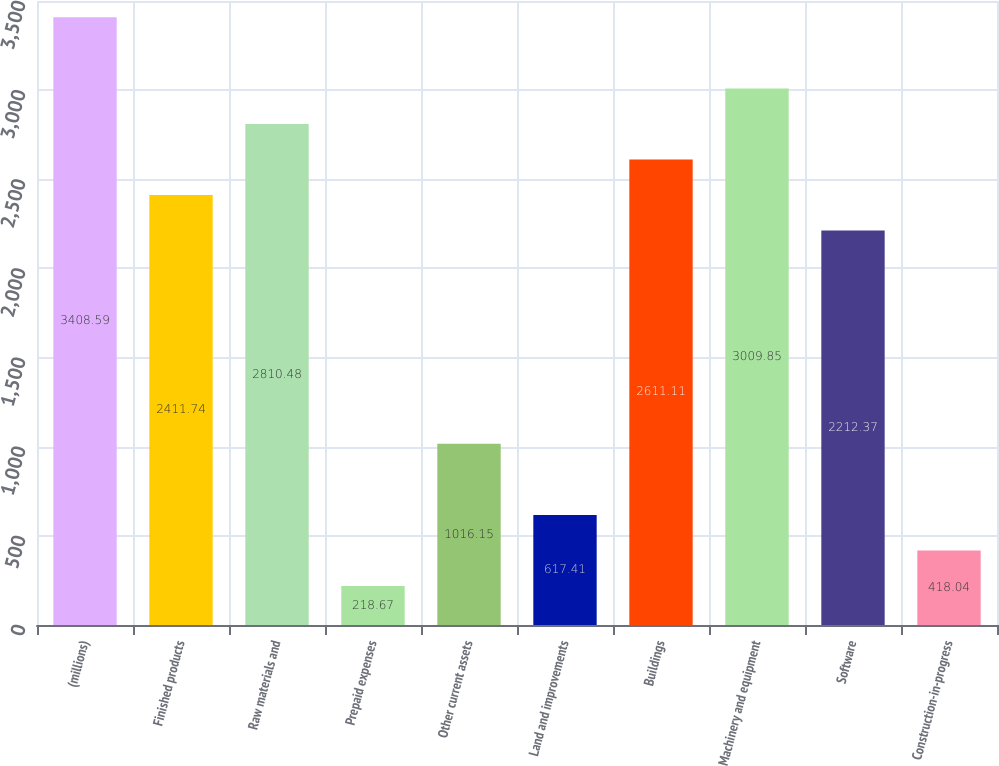Convert chart to OTSL. <chart><loc_0><loc_0><loc_500><loc_500><bar_chart><fcel>(millions)<fcel>Finished products<fcel>Raw materials and<fcel>Prepaid expenses<fcel>Other current assets<fcel>Land and improvements<fcel>Buildings<fcel>Machinery and equipment<fcel>Software<fcel>Construction-in-progress<nl><fcel>3408.59<fcel>2411.74<fcel>2810.48<fcel>218.67<fcel>1016.15<fcel>617.41<fcel>2611.11<fcel>3009.85<fcel>2212.37<fcel>418.04<nl></chart> 